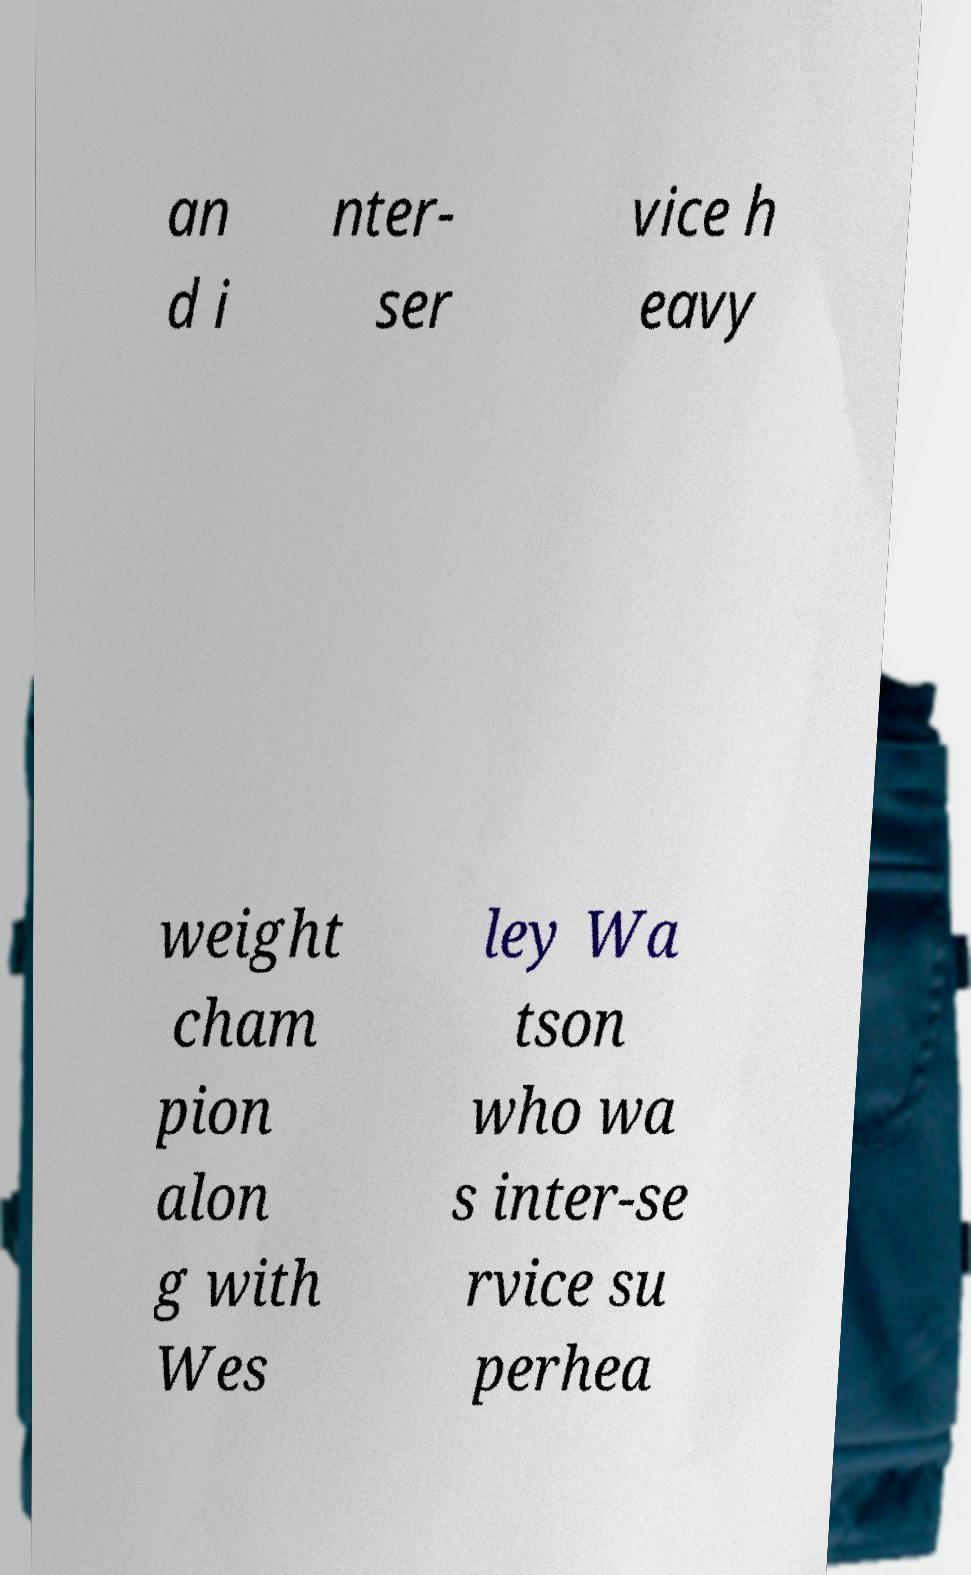Could you assist in decoding the text presented in this image and type it out clearly? an d i nter- ser vice h eavy weight cham pion alon g with Wes ley Wa tson who wa s inter-se rvice su perhea 